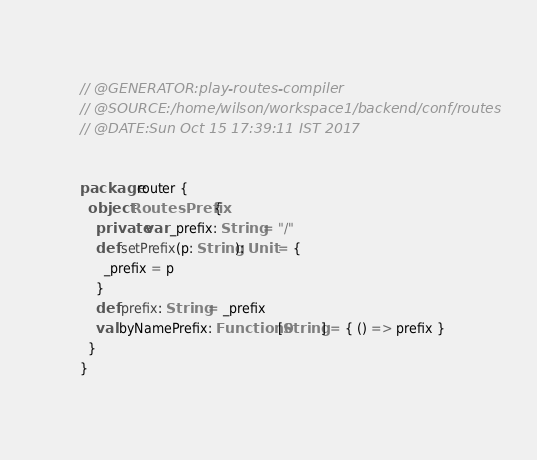Convert code to text. <code><loc_0><loc_0><loc_500><loc_500><_Scala_>
// @GENERATOR:play-routes-compiler
// @SOURCE:/home/wilson/workspace1/backend/conf/routes
// @DATE:Sun Oct 15 17:39:11 IST 2017


package router {
  object RoutesPrefix {
    private var _prefix: String = "/"
    def setPrefix(p: String): Unit = {
      _prefix = p
    }
    def prefix: String = _prefix
    val byNamePrefix: Function0[String] = { () => prefix }
  }
}
</code> 